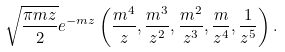<formula> <loc_0><loc_0><loc_500><loc_500>\sqrt { \frac { \pi m z } { 2 } } e ^ { - m z } \left ( \frac { m ^ { 4 } } { z } , \frac { m ^ { 3 } } { z ^ { 2 } } , \frac { m ^ { 2 } } { z ^ { 3 } } , \frac { m } { z ^ { 4 } } , \frac { 1 } { z ^ { 5 } } \right ) .</formula> 